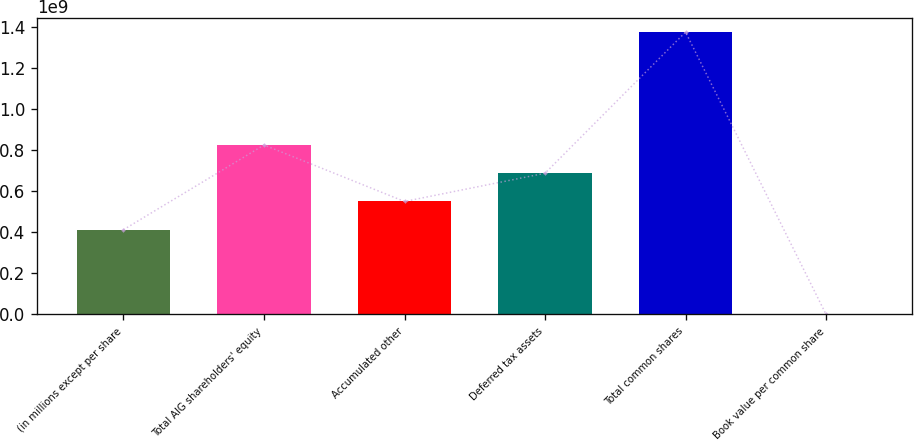<chart> <loc_0><loc_0><loc_500><loc_500><bar_chart><fcel>(in millions except per share<fcel>Total AIG shareholders' equity<fcel>Accumulated other<fcel>Deferred tax assets<fcel>Total common shares<fcel>Book value per common share<nl><fcel>4.12778e+08<fcel>8.25556e+08<fcel>5.50371e+08<fcel>6.87964e+08<fcel>1.37593e+09<fcel>58.23<nl></chart> 